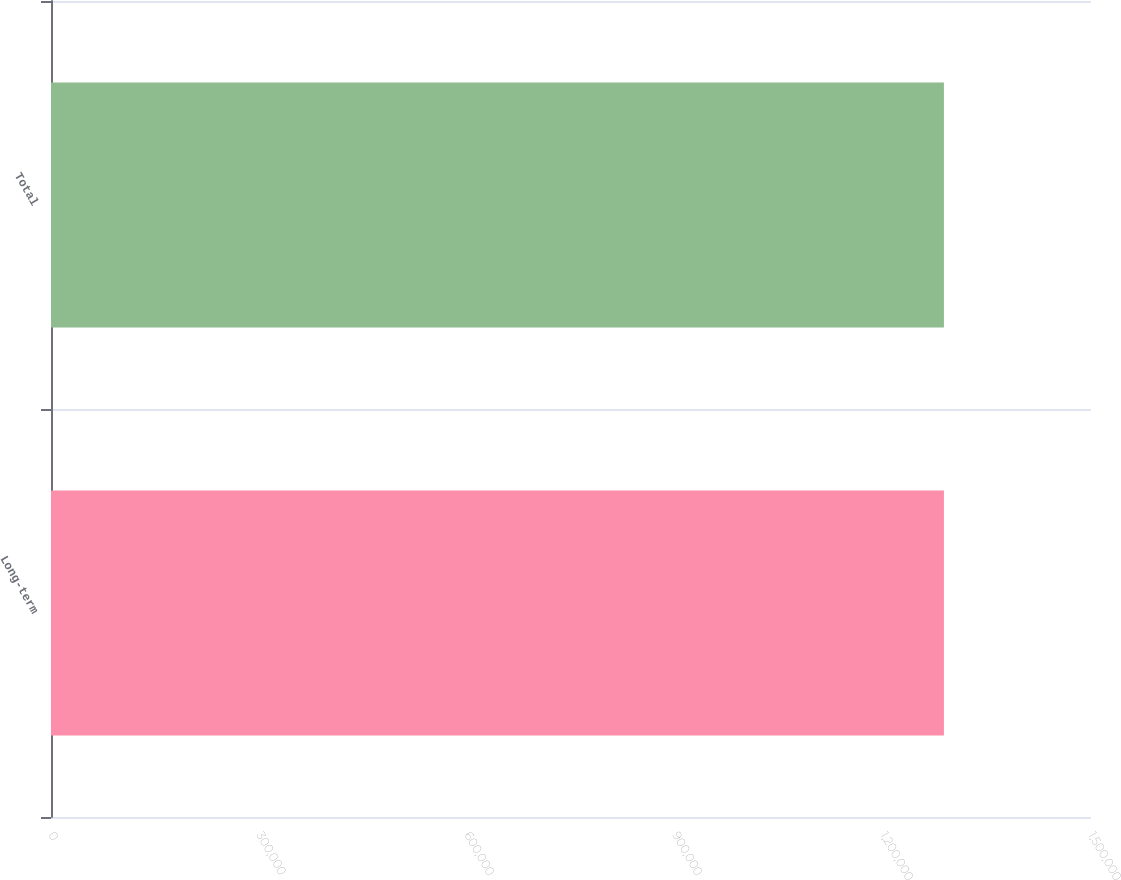Convert chart. <chart><loc_0><loc_0><loc_500><loc_500><bar_chart><fcel>Long-term<fcel>Total<nl><fcel>1.28788e+06<fcel>1.28788e+06<nl></chart> 